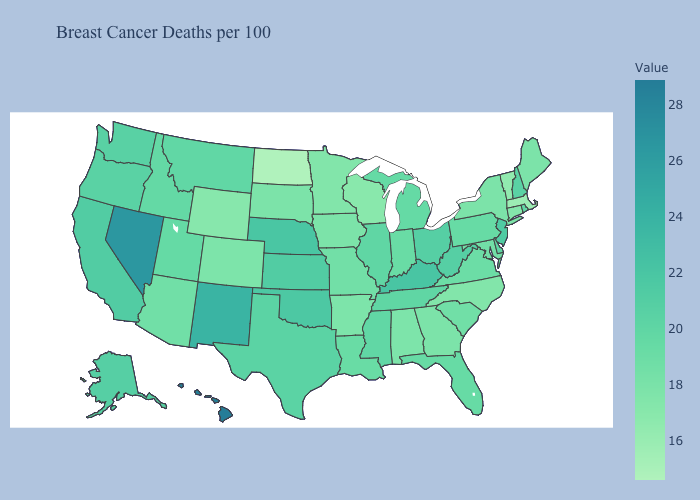Does the map have missing data?
Be succinct. No. Among the states that border Arizona , does Nevada have the highest value?
Answer briefly. Yes. Does North Dakota have the lowest value in the USA?
Give a very brief answer. Yes. Is the legend a continuous bar?
Short answer required. Yes. Does Texas have the highest value in the USA?
Short answer required. No. Does North Dakota have the lowest value in the USA?
Quick response, please. Yes. Which states have the lowest value in the USA?
Short answer required. North Dakota. 